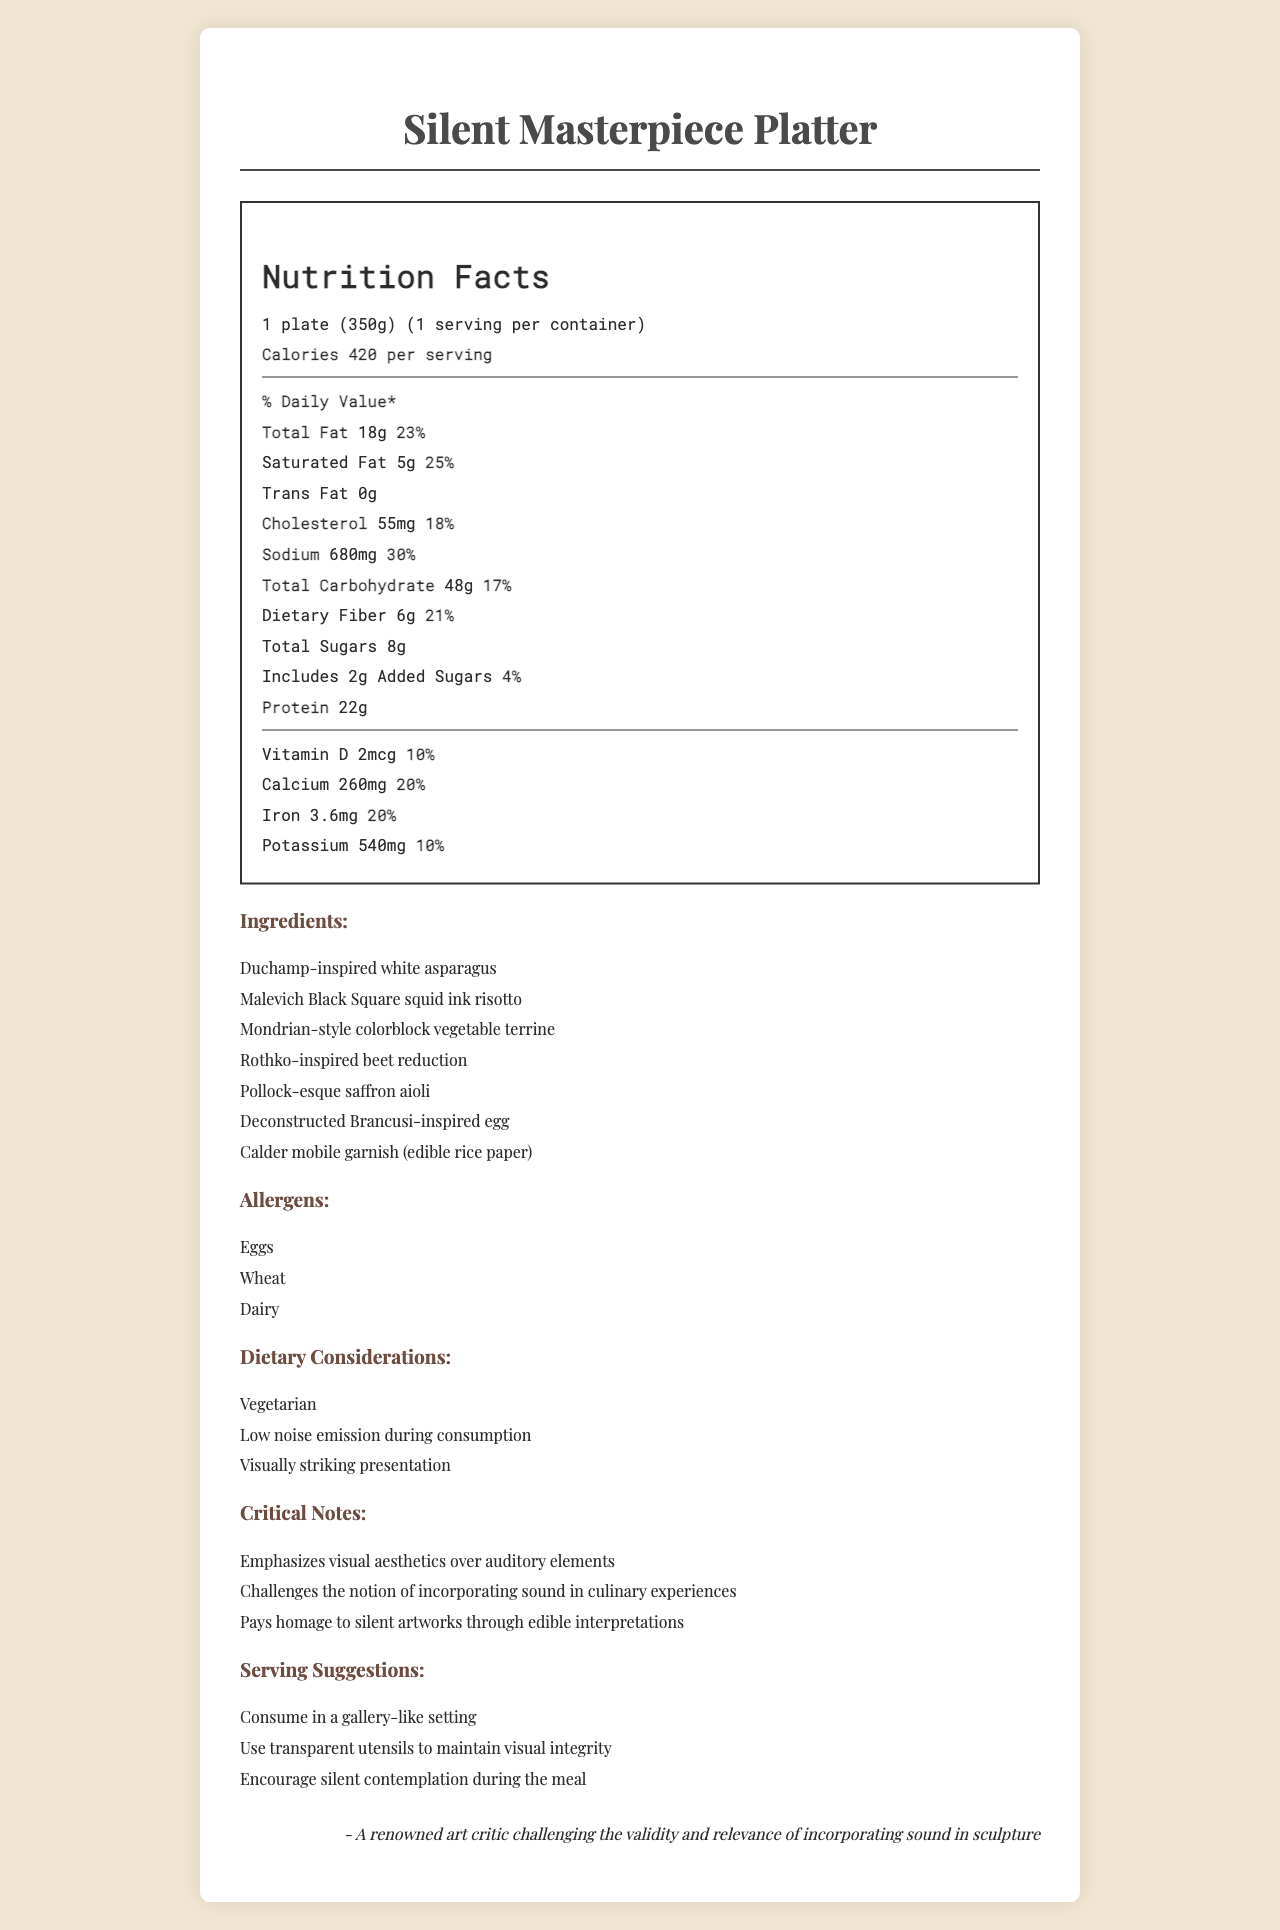what is the serving size? The serving size is written at the beginning of the nutrition label as "1 plate (350g)".
Answer: 1 plate (350g) how many calories does one serving have? The calories per serving are listed as "Calories 420 per serving".
Answer: 420 how much protein is in the Silent Masterpiece Platter? The amount of protein is listed as "Protein 22g".
Answer: 22g what percentage of the daily value of total fat does one serving provide? The percentage of daily value for total fat is noted as "Total Fat 18g 23%".
Answer: 23% What is one of the key ingredients in the platter? The ingredients list includes "Duchamp-inspired white asparagus" among other items.
Answer: Duchamp-inspired white asparagus what is the amount of cholesterol per serving? A. 30mg B. 45mg C. 180mg D. 55mg The document lists the cholesterol content as "Cholesterol 55mg".
Answer: D. 55mg Which of the following dietary considerations does the meal emphasize? A. Vegan B. Gluten-Free C. Low noise emission during consumption D. High-protein The dietary considerations specified include "Low noise emission during consumption".
Answer: C. Low noise emission during consumption Is the meal intended for vegetarian consumers? The dietary considerations section lists "Vegetarian".
Answer: Yes is there any added sugar in the meal? The document shows "Includes 2g Added Sugars".
Answer: Yes Should the meal be consumed in a noisy environment? The serving suggestions emphasize consuming the meal in a "gallery-like setting" and encouraging "silent contemplation during the meal".
Answer: No how much saturated fat is in each serving? The amount of saturated fat is listed as "Saturated Fat 5g".
Answer: 5g Does this meal contain any allergens? There is a dedicated section listing "Eggs", "Wheat", and "Dairy".
Answer: Yes Summarize the main idea of the document. The summary covers the key aspects of the document, such as its emphasis on visual aesthetics, the nutritional details, dietary considerations, and the intended silent dining experience.
Answer: The document is a Nutrition Facts Label for the "Silent Masterpiece Platter," emphasizing its visual aesthetics inspired by iconic silent artworks. It provides detailed nutritional information, ingredients, allergens, dietary considerations, critical notes, and serving suggestions. The meal is designed to be enjoyed in a silent, contemplative setting and challenges the incorporation of auditory elements in artwork. Which is higher in daily value percentage: protein or calcium? The % Daily Values listed are 44% for protein and 20% for calcium.
Answer: Protein what is the sodium content per serving? The sodium content is listed as "Sodium 680mg".
Answer: 680mg What temperature should the food be served at? The document provides detailed nutritional information, ingredients, dietary considerations, and serving suggestions but does not mention the serving temperature.
Answer: Cannot be determined 